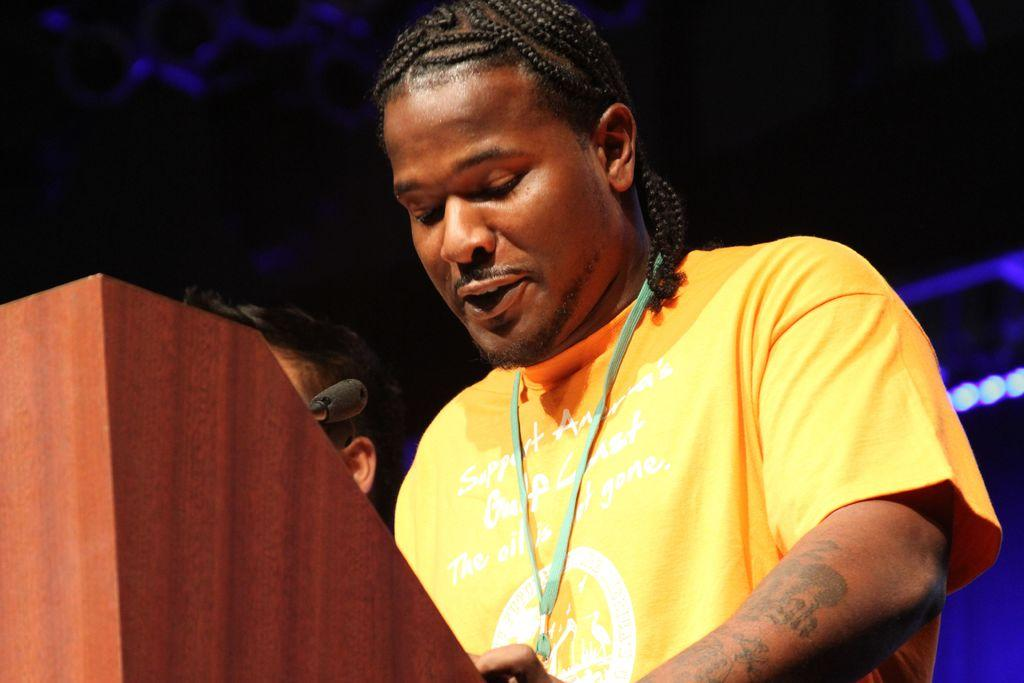How many people are on the stage in the image? There are two persons standing on the stage. What is present in front of the persons on the stage? There is a table with a microphone in front of the persons. What can be observed about the background of the image? The background of the image is dark. What type of journey are the women taking in the image? There are no women present in the image, and no journey is depicted. Is there a bath visible in the image? There is no bath present in the image. 